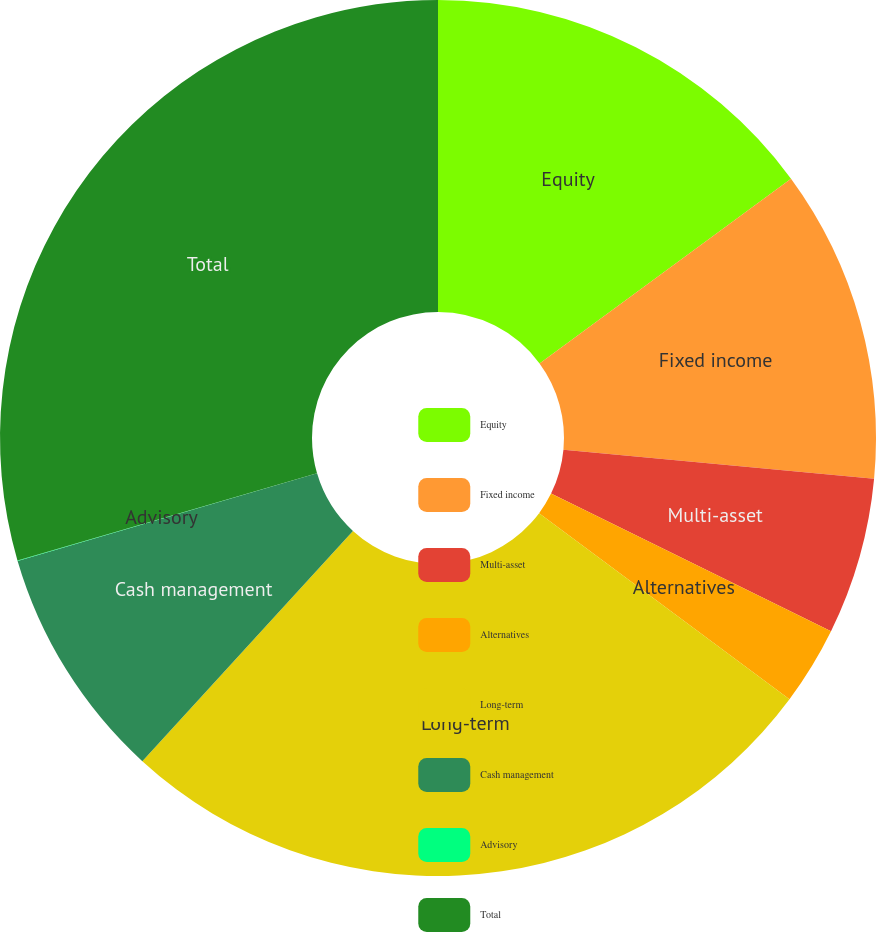<chart> <loc_0><loc_0><loc_500><loc_500><pie_chart><fcel>Equity<fcel>Fixed income<fcel>Multi-asset<fcel>Alternatives<fcel>Long-term<fcel>Cash management<fcel>Advisory<fcel>Total<nl><fcel>14.92%<fcel>11.57%<fcel>5.79%<fcel>2.9%<fcel>26.62%<fcel>8.68%<fcel>0.02%<fcel>29.51%<nl></chart> 